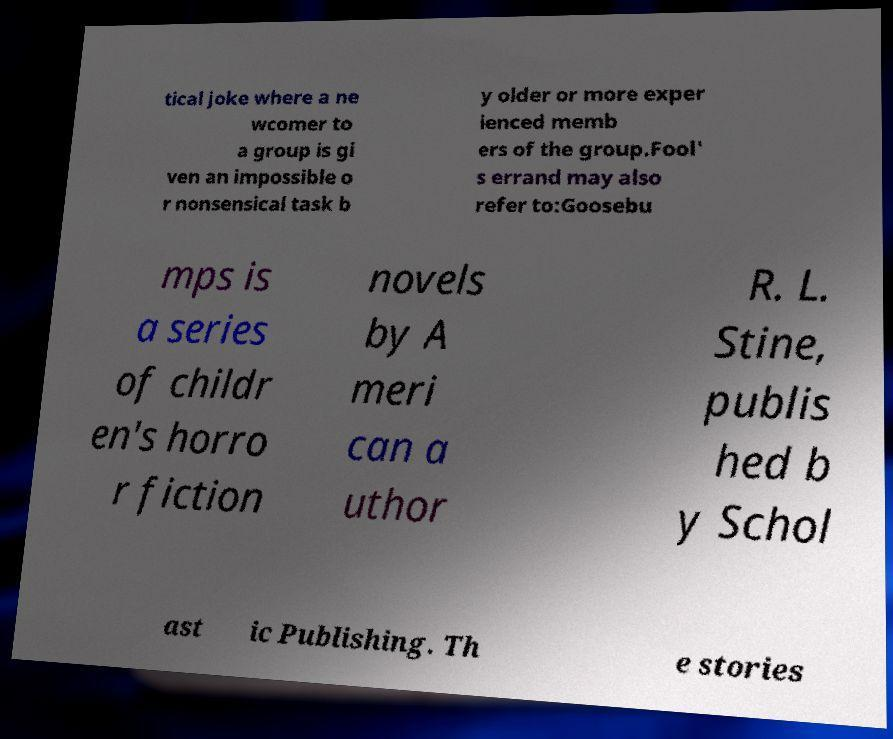Can you read and provide the text displayed in the image?This photo seems to have some interesting text. Can you extract and type it out for me? tical joke where a ne wcomer to a group is gi ven an impossible o r nonsensical task b y older or more exper ienced memb ers of the group.Fool' s errand may also refer to:Goosebu mps is a series of childr en's horro r fiction novels by A meri can a uthor R. L. Stine, publis hed b y Schol ast ic Publishing. Th e stories 